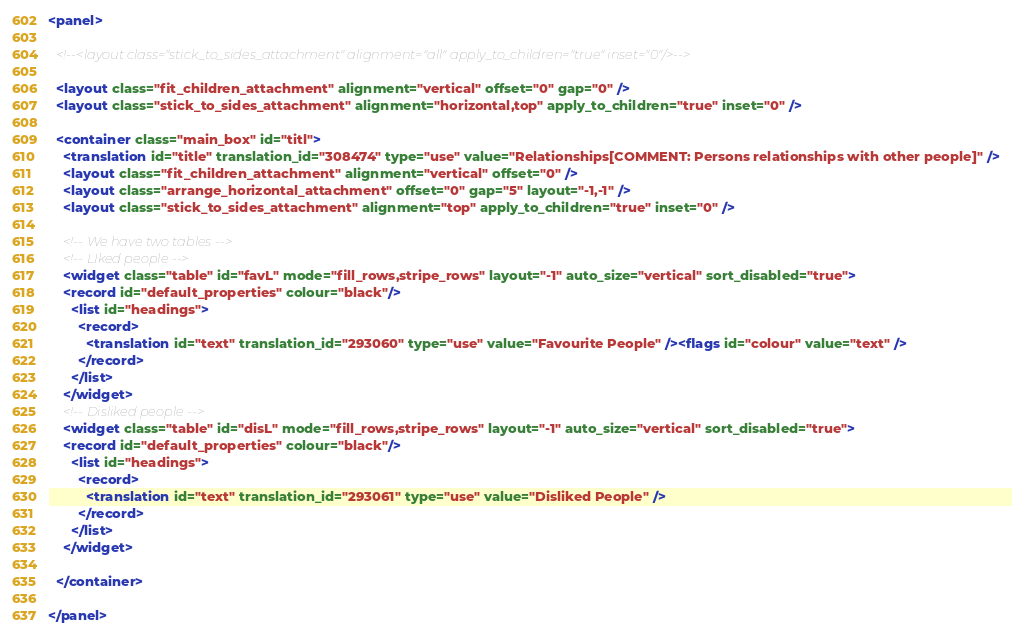<code> <loc_0><loc_0><loc_500><loc_500><_XML_><panel>

  <!--<layout class="stick_to_sides_attachment" alignment="all" apply_to_children="true" inset="0"/>-->

  <layout class="fit_children_attachment" alignment="vertical" offset="0" gap="0" />
  <layout class="stick_to_sides_attachment" alignment="horizontal,top" apply_to_children="true" inset="0" />

  <container class="main_box" id="titl">
    <translation id="title" translation_id="308474" type="use" value="Relationships[COMMENT: Persons relationships with other people]" />
    <layout class="fit_children_attachment" alignment="vertical" offset="0" />
    <layout class="arrange_horizontal_attachment" offset="0" gap="5" layout="-1,-1" />
    <layout class="stick_to_sides_attachment" alignment="top" apply_to_children="true" inset="0" />

    <!-- We have two tables -->
    <!-- LIked people -->
    <widget class="table" id="favL" mode="fill_rows,stripe_rows" layout="-1" auto_size="vertical" sort_disabled="true">
	<record id="default_properties" colour="black"/>
      <list id="headings">
        <record>
          <translation id="text" translation_id="293060" type="use" value="Favourite People" /><flags id="colour" value="text" />
        </record>
      </list>
    </widget>
    <!-- Disliked people -->
    <widget class="table" id="disL" mode="fill_rows,stripe_rows" layout="-1" auto_size="vertical" sort_disabled="true">
	<record id="default_properties" colour="black"/>
      <list id="headings">
        <record>
          <translation id="text" translation_id="293061" type="use" value="Disliked People" />
        </record>
      </list>
    </widget>

  </container>

</panel></code> 